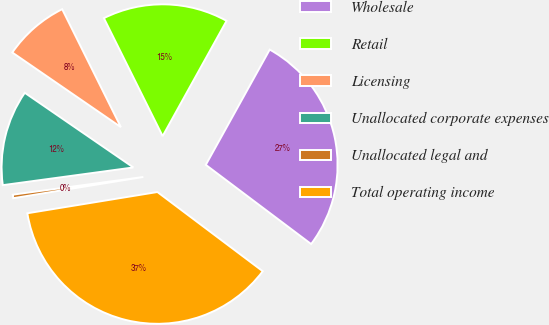<chart> <loc_0><loc_0><loc_500><loc_500><pie_chart><fcel>Wholesale<fcel>Retail<fcel>Licensing<fcel>Unallocated corporate expenses<fcel>Unallocated legal and<fcel>Total operating income<nl><fcel>27.2%<fcel>15.41%<fcel>8.06%<fcel>11.73%<fcel>0.43%<fcel>37.16%<nl></chart> 